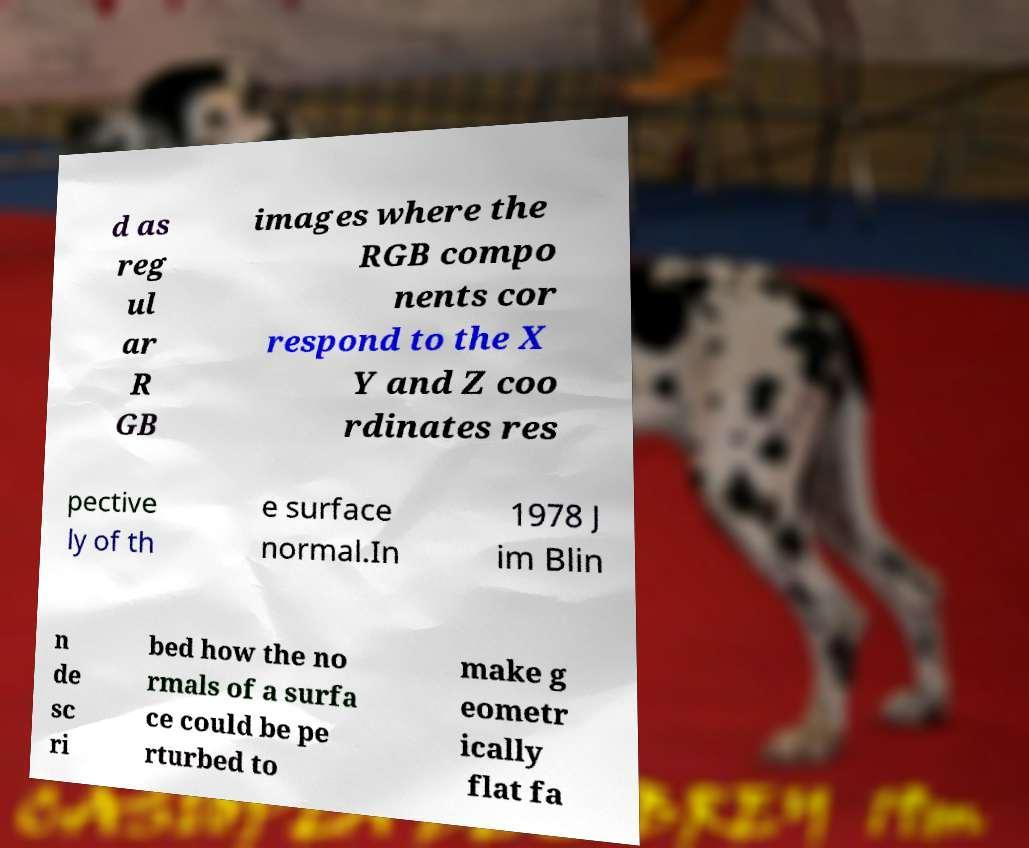Please read and relay the text visible in this image. What does it say? d as reg ul ar R GB images where the RGB compo nents cor respond to the X Y and Z coo rdinates res pective ly of th e surface normal.In 1978 J im Blin n de sc ri bed how the no rmals of a surfa ce could be pe rturbed to make g eometr ically flat fa 